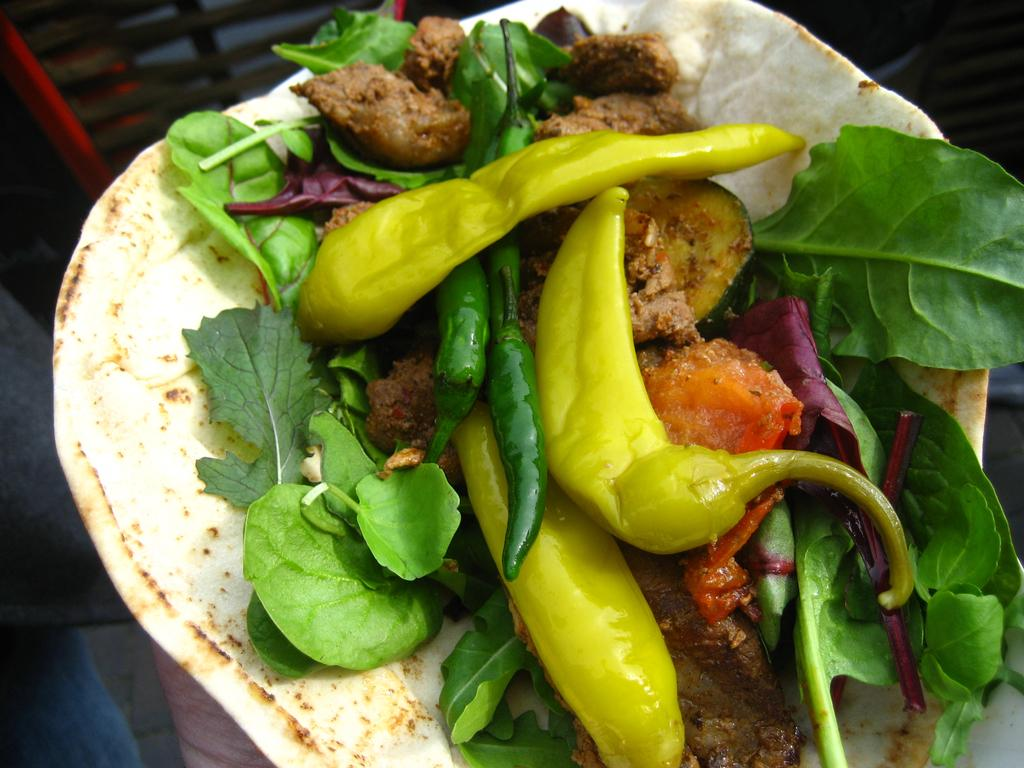What is the main subject of the image? The main subject of the image is food. Can you describe the background of the image? The background of the image is blurry. What type of square object is present in the image? There is no square object present in the image; it only features food and a blurry background. How does the food in the image make you feel? The image does not convey any feelings or emotions, as it only shows food and a blurry background. 